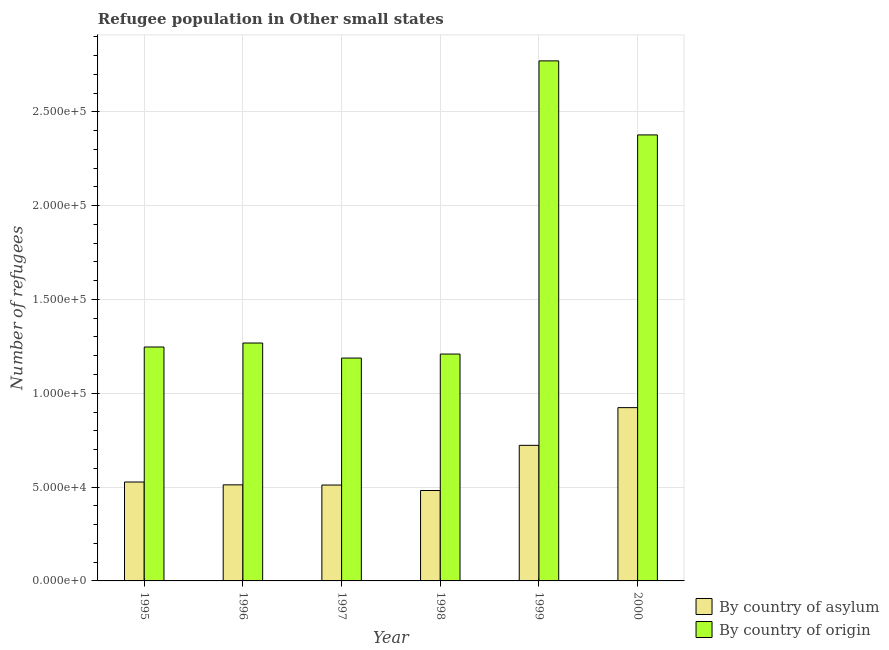How many groups of bars are there?
Provide a short and direct response. 6. Are the number of bars per tick equal to the number of legend labels?
Your answer should be very brief. Yes. In how many cases, is the number of bars for a given year not equal to the number of legend labels?
Ensure brevity in your answer.  0. What is the number of refugees by country of origin in 1996?
Your answer should be very brief. 1.27e+05. Across all years, what is the maximum number of refugees by country of origin?
Offer a terse response. 2.77e+05. Across all years, what is the minimum number of refugees by country of asylum?
Offer a very short reply. 4.82e+04. In which year was the number of refugees by country of asylum maximum?
Offer a terse response. 2000. In which year was the number of refugees by country of origin minimum?
Give a very brief answer. 1997. What is the total number of refugees by country of origin in the graph?
Your answer should be very brief. 1.01e+06. What is the difference between the number of refugees by country of origin in 1995 and that in 1996?
Ensure brevity in your answer.  -2124. What is the difference between the number of refugees by country of asylum in 1998 and the number of refugees by country of origin in 1996?
Give a very brief answer. -3013. What is the average number of refugees by country of origin per year?
Ensure brevity in your answer.  1.68e+05. What is the ratio of the number of refugees by country of asylum in 1996 to that in 1999?
Offer a terse response. 0.71. Is the difference between the number of refugees by country of origin in 1998 and 1999 greater than the difference between the number of refugees by country of asylum in 1998 and 1999?
Offer a very short reply. No. What is the difference between the highest and the second highest number of refugees by country of asylum?
Make the answer very short. 2.01e+04. What is the difference between the highest and the lowest number of refugees by country of origin?
Your response must be concise. 1.58e+05. In how many years, is the number of refugees by country of asylum greater than the average number of refugees by country of asylum taken over all years?
Make the answer very short. 2. What does the 2nd bar from the left in 1998 represents?
Give a very brief answer. By country of origin. What does the 1st bar from the right in 1996 represents?
Give a very brief answer. By country of origin. Are all the bars in the graph horizontal?
Your response must be concise. No. How many years are there in the graph?
Give a very brief answer. 6. Are the values on the major ticks of Y-axis written in scientific E-notation?
Make the answer very short. Yes. How are the legend labels stacked?
Your answer should be very brief. Vertical. What is the title of the graph?
Your answer should be compact. Refugee population in Other small states. What is the label or title of the X-axis?
Offer a terse response. Year. What is the label or title of the Y-axis?
Offer a terse response. Number of refugees. What is the Number of refugees in By country of asylum in 1995?
Your response must be concise. 5.27e+04. What is the Number of refugees in By country of origin in 1995?
Offer a very short reply. 1.25e+05. What is the Number of refugees in By country of asylum in 1996?
Make the answer very short. 5.12e+04. What is the Number of refugees of By country of origin in 1996?
Give a very brief answer. 1.27e+05. What is the Number of refugees in By country of asylum in 1997?
Give a very brief answer. 5.11e+04. What is the Number of refugees in By country of origin in 1997?
Keep it short and to the point. 1.19e+05. What is the Number of refugees in By country of asylum in 1998?
Offer a very short reply. 4.82e+04. What is the Number of refugees of By country of origin in 1998?
Provide a succinct answer. 1.21e+05. What is the Number of refugees of By country of asylum in 1999?
Provide a succinct answer. 7.23e+04. What is the Number of refugees in By country of origin in 1999?
Keep it short and to the point. 2.77e+05. What is the Number of refugees in By country of asylum in 2000?
Your answer should be compact. 9.23e+04. What is the Number of refugees of By country of origin in 2000?
Make the answer very short. 2.38e+05. Across all years, what is the maximum Number of refugees of By country of asylum?
Provide a short and direct response. 9.23e+04. Across all years, what is the maximum Number of refugees in By country of origin?
Provide a succinct answer. 2.77e+05. Across all years, what is the minimum Number of refugees in By country of asylum?
Provide a succinct answer. 4.82e+04. Across all years, what is the minimum Number of refugees in By country of origin?
Offer a terse response. 1.19e+05. What is the total Number of refugees in By country of asylum in the graph?
Offer a very short reply. 3.68e+05. What is the total Number of refugees in By country of origin in the graph?
Offer a terse response. 1.01e+06. What is the difference between the Number of refugees in By country of asylum in 1995 and that in 1996?
Offer a terse response. 1518. What is the difference between the Number of refugees of By country of origin in 1995 and that in 1996?
Your answer should be compact. -2124. What is the difference between the Number of refugees of By country of asylum in 1995 and that in 1997?
Offer a very short reply. 1613. What is the difference between the Number of refugees of By country of origin in 1995 and that in 1997?
Your answer should be very brief. 5896. What is the difference between the Number of refugees of By country of asylum in 1995 and that in 1998?
Keep it short and to the point. 4531. What is the difference between the Number of refugees in By country of origin in 1995 and that in 1998?
Your answer should be compact. 3760. What is the difference between the Number of refugees in By country of asylum in 1995 and that in 1999?
Your response must be concise. -1.95e+04. What is the difference between the Number of refugees in By country of origin in 1995 and that in 1999?
Provide a short and direct response. -1.52e+05. What is the difference between the Number of refugees in By country of asylum in 1995 and that in 2000?
Your answer should be compact. -3.96e+04. What is the difference between the Number of refugees of By country of origin in 1995 and that in 2000?
Provide a succinct answer. -1.13e+05. What is the difference between the Number of refugees in By country of origin in 1996 and that in 1997?
Your answer should be compact. 8020. What is the difference between the Number of refugees of By country of asylum in 1996 and that in 1998?
Your response must be concise. 3013. What is the difference between the Number of refugees of By country of origin in 1996 and that in 1998?
Make the answer very short. 5884. What is the difference between the Number of refugees of By country of asylum in 1996 and that in 1999?
Keep it short and to the point. -2.11e+04. What is the difference between the Number of refugees in By country of origin in 1996 and that in 1999?
Your answer should be very brief. -1.50e+05. What is the difference between the Number of refugees of By country of asylum in 1996 and that in 2000?
Offer a very short reply. -4.12e+04. What is the difference between the Number of refugees of By country of origin in 1996 and that in 2000?
Your response must be concise. -1.11e+05. What is the difference between the Number of refugees of By country of asylum in 1997 and that in 1998?
Give a very brief answer. 2918. What is the difference between the Number of refugees of By country of origin in 1997 and that in 1998?
Give a very brief answer. -2136. What is the difference between the Number of refugees in By country of asylum in 1997 and that in 1999?
Your response must be concise. -2.12e+04. What is the difference between the Number of refugees in By country of origin in 1997 and that in 1999?
Your answer should be very brief. -1.58e+05. What is the difference between the Number of refugees of By country of asylum in 1997 and that in 2000?
Your answer should be compact. -4.12e+04. What is the difference between the Number of refugees in By country of origin in 1997 and that in 2000?
Offer a very short reply. -1.19e+05. What is the difference between the Number of refugees of By country of asylum in 1998 and that in 1999?
Make the answer very short. -2.41e+04. What is the difference between the Number of refugees in By country of origin in 1998 and that in 1999?
Provide a succinct answer. -1.56e+05. What is the difference between the Number of refugees of By country of asylum in 1998 and that in 2000?
Give a very brief answer. -4.42e+04. What is the difference between the Number of refugees in By country of origin in 1998 and that in 2000?
Keep it short and to the point. -1.17e+05. What is the difference between the Number of refugees of By country of asylum in 1999 and that in 2000?
Offer a terse response. -2.01e+04. What is the difference between the Number of refugees of By country of origin in 1999 and that in 2000?
Ensure brevity in your answer.  3.95e+04. What is the difference between the Number of refugees of By country of asylum in 1995 and the Number of refugees of By country of origin in 1996?
Your answer should be very brief. -7.41e+04. What is the difference between the Number of refugees of By country of asylum in 1995 and the Number of refugees of By country of origin in 1997?
Give a very brief answer. -6.60e+04. What is the difference between the Number of refugees in By country of asylum in 1995 and the Number of refugees in By country of origin in 1998?
Your answer should be very brief. -6.82e+04. What is the difference between the Number of refugees in By country of asylum in 1995 and the Number of refugees in By country of origin in 1999?
Your answer should be very brief. -2.24e+05. What is the difference between the Number of refugees in By country of asylum in 1995 and the Number of refugees in By country of origin in 2000?
Offer a terse response. -1.85e+05. What is the difference between the Number of refugees in By country of asylum in 1996 and the Number of refugees in By country of origin in 1997?
Make the answer very short. -6.76e+04. What is the difference between the Number of refugees of By country of asylum in 1996 and the Number of refugees of By country of origin in 1998?
Provide a short and direct response. -6.97e+04. What is the difference between the Number of refugees in By country of asylum in 1996 and the Number of refugees in By country of origin in 1999?
Give a very brief answer. -2.26e+05. What is the difference between the Number of refugees of By country of asylum in 1996 and the Number of refugees of By country of origin in 2000?
Ensure brevity in your answer.  -1.86e+05. What is the difference between the Number of refugees of By country of asylum in 1997 and the Number of refugees of By country of origin in 1998?
Provide a succinct answer. -6.98e+04. What is the difference between the Number of refugees in By country of asylum in 1997 and the Number of refugees in By country of origin in 1999?
Your answer should be very brief. -2.26e+05. What is the difference between the Number of refugees in By country of asylum in 1997 and the Number of refugees in By country of origin in 2000?
Make the answer very short. -1.87e+05. What is the difference between the Number of refugees in By country of asylum in 1998 and the Number of refugees in By country of origin in 1999?
Ensure brevity in your answer.  -2.29e+05. What is the difference between the Number of refugees of By country of asylum in 1998 and the Number of refugees of By country of origin in 2000?
Offer a terse response. -1.89e+05. What is the difference between the Number of refugees in By country of asylum in 1999 and the Number of refugees in By country of origin in 2000?
Keep it short and to the point. -1.65e+05. What is the average Number of refugees of By country of asylum per year?
Your answer should be very brief. 6.13e+04. What is the average Number of refugees in By country of origin per year?
Provide a short and direct response. 1.68e+05. In the year 1995, what is the difference between the Number of refugees in By country of asylum and Number of refugees in By country of origin?
Your answer should be compact. -7.19e+04. In the year 1996, what is the difference between the Number of refugees in By country of asylum and Number of refugees in By country of origin?
Offer a terse response. -7.56e+04. In the year 1997, what is the difference between the Number of refugees in By country of asylum and Number of refugees in By country of origin?
Your answer should be very brief. -6.77e+04. In the year 1998, what is the difference between the Number of refugees in By country of asylum and Number of refugees in By country of origin?
Keep it short and to the point. -7.27e+04. In the year 1999, what is the difference between the Number of refugees of By country of asylum and Number of refugees of By country of origin?
Keep it short and to the point. -2.05e+05. In the year 2000, what is the difference between the Number of refugees in By country of asylum and Number of refugees in By country of origin?
Offer a very short reply. -1.45e+05. What is the ratio of the Number of refugees of By country of asylum in 1995 to that in 1996?
Offer a very short reply. 1.03. What is the ratio of the Number of refugees of By country of origin in 1995 to that in 1996?
Provide a short and direct response. 0.98. What is the ratio of the Number of refugees in By country of asylum in 1995 to that in 1997?
Provide a succinct answer. 1.03. What is the ratio of the Number of refugees in By country of origin in 1995 to that in 1997?
Offer a terse response. 1.05. What is the ratio of the Number of refugees of By country of asylum in 1995 to that in 1998?
Ensure brevity in your answer.  1.09. What is the ratio of the Number of refugees of By country of origin in 1995 to that in 1998?
Make the answer very short. 1.03. What is the ratio of the Number of refugees in By country of asylum in 1995 to that in 1999?
Offer a terse response. 0.73. What is the ratio of the Number of refugees of By country of origin in 1995 to that in 1999?
Provide a short and direct response. 0.45. What is the ratio of the Number of refugees in By country of asylum in 1995 to that in 2000?
Provide a short and direct response. 0.57. What is the ratio of the Number of refugees in By country of origin in 1995 to that in 2000?
Your response must be concise. 0.52. What is the ratio of the Number of refugees in By country of asylum in 1996 to that in 1997?
Ensure brevity in your answer.  1. What is the ratio of the Number of refugees in By country of origin in 1996 to that in 1997?
Ensure brevity in your answer.  1.07. What is the ratio of the Number of refugees in By country of origin in 1996 to that in 1998?
Provide a short and direct response. 1.05. What is the ratio of the Number of refugees of By country of asylum in 1996 to that in 1999?
Your answer should be very brief. 0.71. What is the ratio of the Number of refugees in By country of origin in 1996 to that in 1999?
Provide a short and direct response. 0.46. What is the ratio of the Number of refugees in By country of asylum in 1996 to that in 2000?
Offer a very short reply. 0.55. What is the ratio of the Number of refugees in By country of origin in 1996 to that in 2000?
Your answer should be very brief. 0.53. What is the ratio of the Number of refugees in By country of asylum in 1997 to that in 1998?
Keep it short and to the point. 1.06. What is the ratio of the Number of refugees in By country of origin in 1997 to that in 1998?
Your response must be concise. 0.98. What is the ratio of the Number of refugees in By country of asylum in 1997 to that in 1999?
Ensure brevity in your answer.  0.71. What is the ratio of the Number of refugees of By country of origin in 1997 to that in 1999?
Keep it short and to the point. 0.43. What is the ratio of the Number of refugees in By country of asylum in 1997 to that in 2000?
Ensure brevity in your answer.  0.55. What is the ratio of the Number of refugees of By country of origin in 1997 to that in 2000?
Ensure brevity in your answer.  0.5. What is the ratio of the Number of refugees of By country of asylum in 1998 to that in 1999?
Ensure brevity in your answer.  0.67. What is the ratio of the Number of refugees in By country of origin in 1998 to that in 1999?
Keep it short and to the point. 0.44. What is the ratio of the Number of refugees of By country of asylum in 1998 to that in 2000?
Make the answer very short. 0.52. What is the ratio of the Number of refugees of By country of origin in 1998 to that in 2000?
Your answer should be very brief. 0.51. What is the ratio of the Number of refugees of By country of asylum in 1999 to that in 2000?
Your answer should be very brief. 0.78. What is the ratio of the Number of refugees of By country of origin in 1999 to that in 2000?
Keep it short and to the point. 1.17. What is the difference between the highest and the second highest Number of refugees of By country of asylum?
Offer a terse response. 2.01e+04. What is the difference between the highest and the second highest Number of refugees in By country of origin?
Ensure brevity in your answer.  3.95e+04. What is the difference between the highest and the lowest Number of refugees in By country of asylum?
Your response must be concise. 4.42e+04. What is the difference between the highest and the lowest Number of refugees in By country of origin?
Offer a terse response. 1.58e+05. 